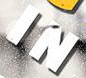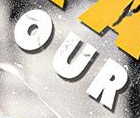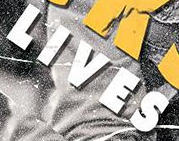Identify the words shown in these images in order, separated by a semicolon. IN; OUR; LIVES 